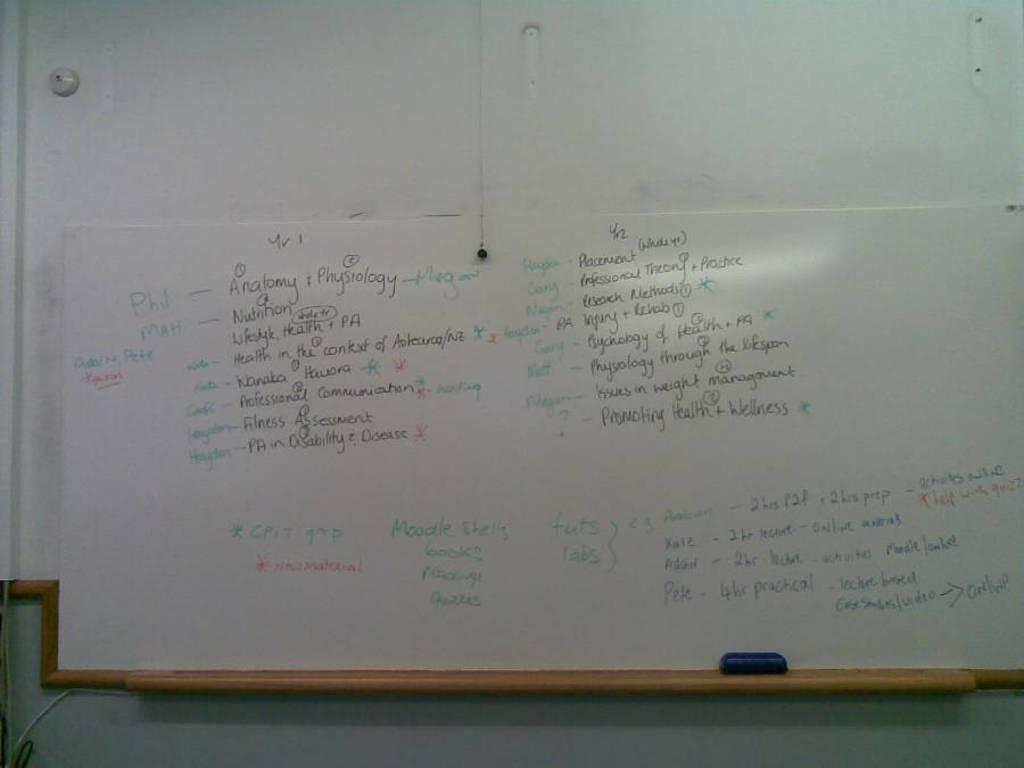<image>
Summarize the visual content of the image. A marker board reads that Phil and Megan will be responsible for Anatomy and Physiology. 